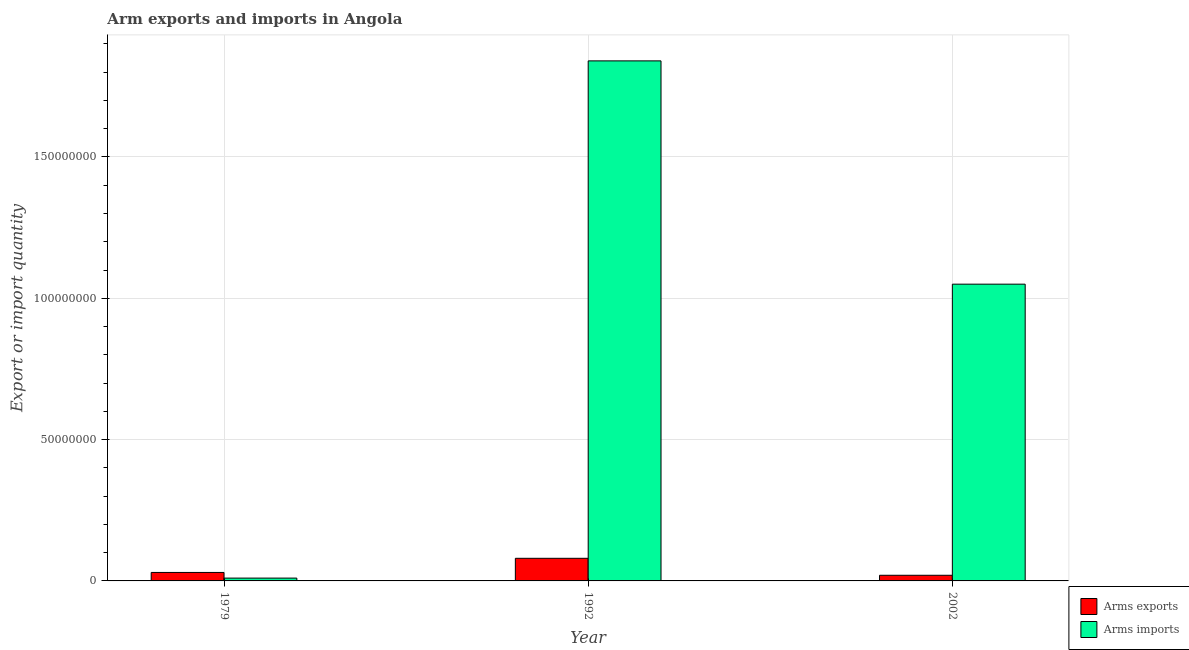How many different coloured bars are there?
Keep it short and to the point. 2. Are the number of bars on each tick of the X-axis equal?
Offer a terse response. Yes. How many bars are there on the 1st tick from the right?
Your answer should be compact. 2. What is the arms exports in 1979?
Make the answer very short. 3.00e+06. Across all years, what is the maximum arms imports?
Keep it short and to the point. 1.84e+08. Across all years, what is the minimum arms exports?
Your response must be concise. 2.00e+06. In which year was the arms exports minimum?
Make the answer very short. 2002. What is the total arms imports in the graph?
Your answer should be compact. 2.90e+08. What is the difference between the arms imports in 1979 and that in 1992?
Keep it short and to the point. -1.83e+08. What is the difference between the arms imports in 1992 and the arms exports in 2002?
Make the answer very short. 7.90e+07. What is the average arms exports per year?
Your answer should be compact. 4.33e+06. In how many years, is the arms imports greater than 150000000?
Offer a terse response. 1. What is the ratio of the arms imports in 1979 to that in 1992?
Your answer should be compact. 0.01. Is the arms exports in 1992 less than that in 2002?
Ensure brevity in your answer.  No. Is the difference between the arms imports in 1979 and 2002 greater than the difference between the arms exports in 1979 and 2002?
Offer a terse response. No. What is the difference between the highest and the second highest arms imports?
Keep it short and to the point. 7.90e+07. What is the difference between the highest and the lowest arms imports?
Keep it short and to the point. 1.83e+08. What does the 2nd bar from the left in 2002 represents?
Your answer should be compact. Arms imports. What does the 2nd bar from the right in 1979 represents?
Offer a very short reply. Arms exports. How many years are there in the graph?
Ensure brevity in your answer.  3. What is the difference between two consecutive major ticks on the Y-axis?
Keep it short and to the point. 5.00e+07. Does the graph contain any zero values?
Offer a very short reply. No. Where does the legend appear in the graph?
Give a very brief answer. Bottom right. How many legend labels are there?
Give a very brief answer. 2. What is the title of the graph?
Ensure brevity in your answer.  Arm exports and imports in Angola. What is the label or title of the X-axis?
Ensure brevity in your answer.  Year. What is the label or title of the Y-axis?
Keep it short and to the point. Export or import quantity. What is the Export or import quantity in Arms imports in 1979?
Your response must be concise. 1.00e+06. What is the Export or import quantity in Arms imports in 1992?
Ensure brevity in your answer.  1.84e+08. What is the Export or import quantity of Arms exports in 2002?
Provide a short and direct response. 2.00e+06. What is the Export or import quantity in Arms imports in 2002?
Your response must be concise. 1.05e+08. Across all years, what is the maximum Export or import quantity in Arms exports?
Provide a succinct answer. 8.00e+06. Across all years, what is the maximum Export or import quantity of Arms imports?
Give a very brief answer. 1.84e+08. Across all years, what is the minimum Export or import quantity in Arms exports?
Your answer should be very brief. 2.00e+06. What is the total Export or import quantity in Arms exports in the graph?
Ensure brevity in your answer.  1.30e+07. What is the total Export or import quantity of Arms imports in the graph?
Ensure brevity in your answer.  2.90e+08. What is the difference between the Export or import quantity in Arms exports in 1979 and that in 1992?
Offer a very short reply. -5.00e+06. What is the difference between the Export or import quantity of Arms imports in 1979 and that in 1992?
Offer a very short reply. -1.83e+08. What is the difference between the Export or import quantity in Arms exports in 1979 and that in 2002?
Offer a very short reply. 1.00e+06. What is the difference between the Export or import quantity of Arms imports in 1979 and that in 2002?
Provide a succinct answer. -1.04e+08. What is the difference between the Export or import quantity in Arms imports in 1992 and that in 2002?
Your response must be concise. 7.90e+07. What is the difference between the Export or import quantity in Arms exports in 1979 and the Export or import quantity in Arms imports in 1992?
Offer a very short reply. -1.81e+08. What is the difference between the Export or import quantity of Arms exports in 1979 and the Export or import quantity of Arms imports in 2002?
Offer a terse response. -1.02e+08. What is the difference between the Export or import quantity in Arms exports in 1992 and the Export or import quantity in Arms imports in 2002?
Your answer should be very brief. -9.70e+07. What is the average Export or import quantity of Arms exports per year?
Keep it short and to the point. 4.33e+06. What is the average Export or import quantity in Arms imports per year?
Make the answer very short. 9.67e+07. In the year 1992, what is the difference between the Export or import quantity in Arms exports and Export or import quantity in Arms imports?
Provide a short and direct response. -1.76e+08. In the year 2002, what is the difference between the Export or import quantity in Arms exports and Export or import quantity in Arms imports?
Keep it short and to the point. -1.03e+08. What is the ratio of the Export or import quantity of Arms exports in 1979 to that in 1992?
Offer a very short reply. 0.38. What is the ratio of the Export or import quantity in Arms imports in 1979 to that in 1992?
Offer a terse response. 0.01. What is the ratio of the Export or import quantity in Arms imports in 1979 to that in 2002?
Your answer should be very brief. 0.01. What is the ratio of the Export or import quantity of Arms imports in 1992 to that in 2002?
Provide a short and direct response. 1.75. What is the difference between the highest and the second highest Export or import quantity in Arms imports?
Your answer should be compact. 7.90e+07. What is the difference between the highest and the lowest Export or import quantity in Arms exports?
Provide a succinct answer. 6.00e+06. What is the difference between the highest and the lowest Export or import quantity in Arms imports?
Offer a terse response. 1.83e+08. 